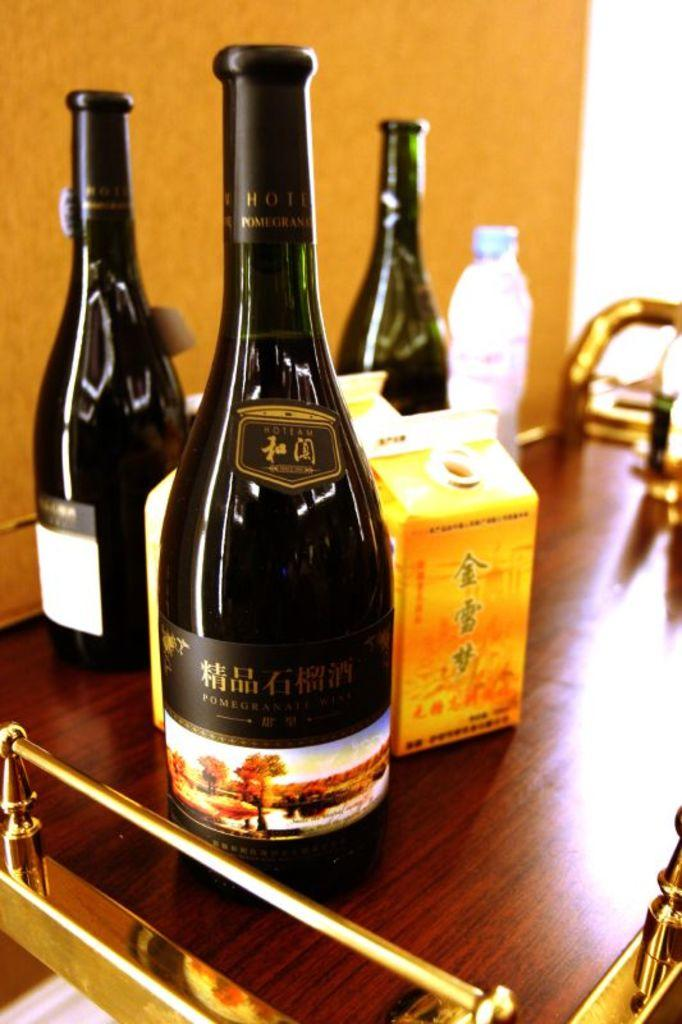How many wine bottles are on the table in the image? There are three wine bottles on the table in the image. What else can be seen on the table besides the wine bottles? There is a box and a small water bottle on the table. What is visible in the background of the image? There is a wall in the background of the image. Can you see anyone playing with a bike in the image? There is no bike or anyone playing with a bike present in the image. 